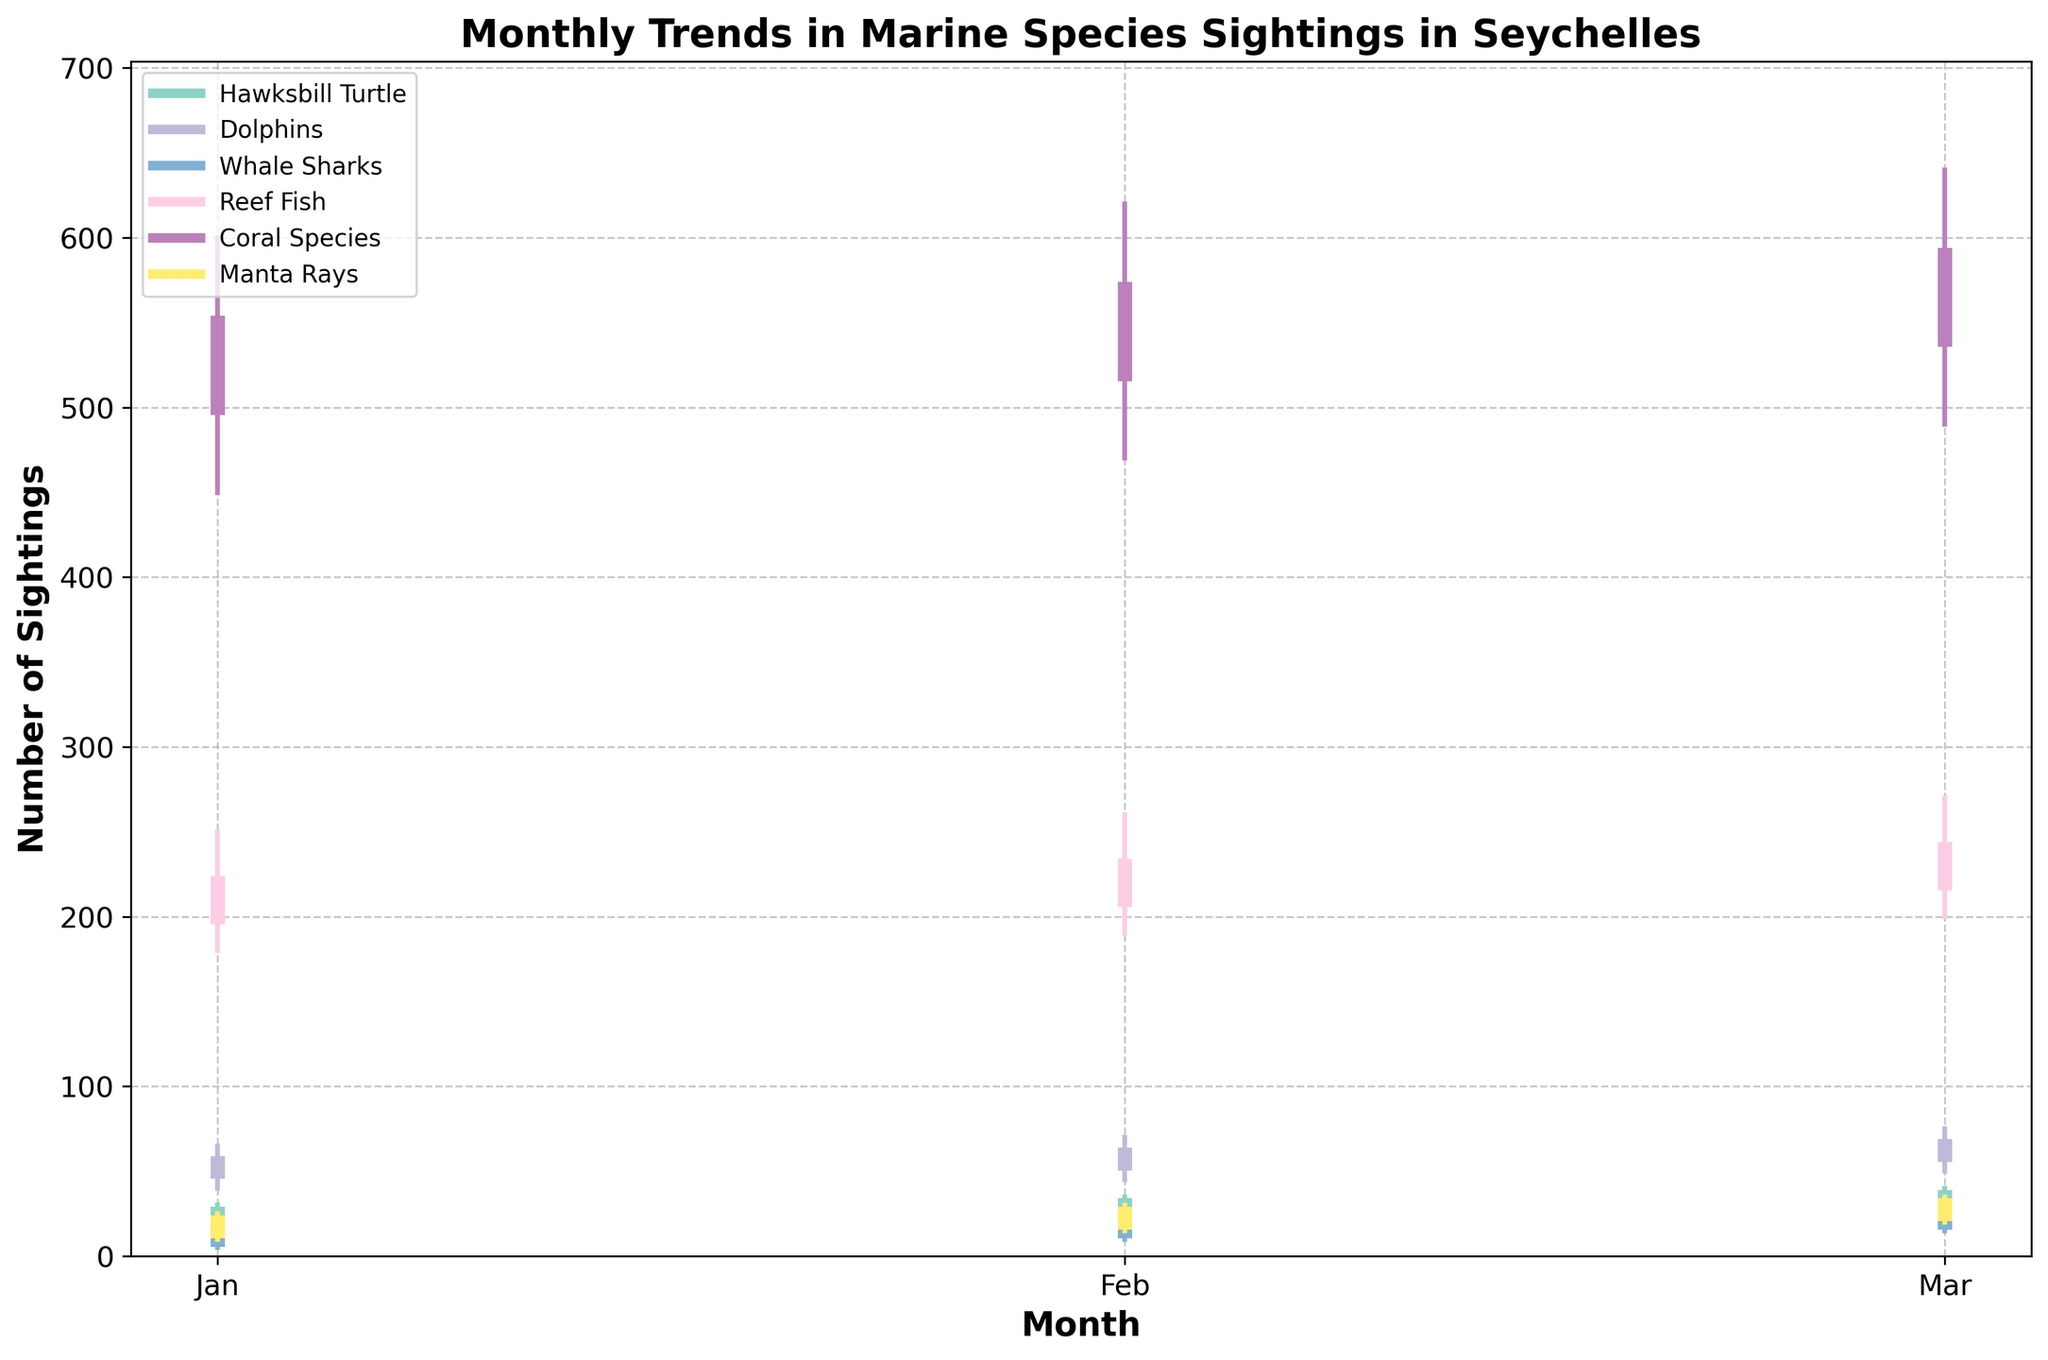What is the title of the figure? The title is typically displayed prominently at the top of the figure. Here, it reads "Monthly Trends in Marine Species Sightings in Seychelles."
Answer: Monthly Trends in Marine Species Sightings in Seychelles Which species has the highest number of sightings in any month? Look for the highest "High" value in the plot. The highest value is associated with "Coral Species" in any of the months, which is 640.
Answer: Coral Species How many different species are represented in the figure? Count the number of unique species names listed in the legend.
Answer: 6 In which month did Dolphins have the highest number of sightings? Identify the month where Dolphins have the highest "High" value in the plot. For Dolphins, the highest value of 75 occurs in March.
Answer: March What's the difference between the highest and lowest sighting values for Whale Sharks in February? For Whale Sharks in February, the highest value is 25, and the lowest value is 10. The difference is computed as 25 - 10.
Answer: 15 Which species shows a consistent increase in the closing number of sightings over the three months? Evaluate each species' closing values over the three months to determine which shows a steady increase. Hawksbill Turtle's closing values are 25, 30, and 35, indicating a consistent increase.
Answer: Hawksbill Turtle Which month had the highest sighting for Manta Rays? And what is the number? By checking the highest points for Manta Rays over the months, March has the highest "High" value which is 35.
Answer: March, 35 How do the number of sightings of Reef Fish in March compare to those in February? Look at the "Close" values for Reef Fish in February and March. For February, it is 230, and for March, it is 240.
Answer: March has more sightings What is the average closing value of Dolphin sightings over the three months? Sum the closing values for Dolphins over the three months (55, 60, and 65), then divide by 3. (55 + 60 + 65) / 3 = 180 / 3
Answer: 60 If you were to rank all species based on their highest single-month number of sightings, which rank does Whale Sharks get? The highest single-month sightings for Whale Sharks is 30 in March. Ranking the species by their highest single-month sighting values: Coral Species (640), Reef Fish (270), Dolphins (75), Hawksbill Turtle (40), Manta Rays (35), Whale Sharks (30). Whale Sharks are 6th.
Answer: 6th 